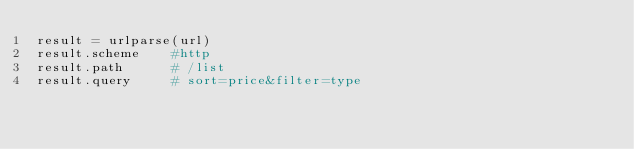<code> <loc_0><loc_0><loc_500><loc_500><_Python_>result = urlparse(url)
result.scheme    #http
result.path      # /list 
result.query     # sort=price&filter=type











</code> 